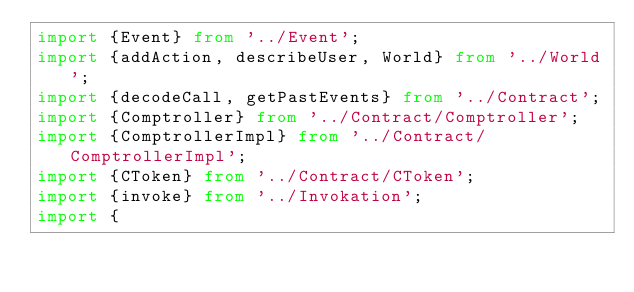Convert code to text. <code><loc_0><loc_0><loc_500><loc_500><_TypeScript_>import {Event} from '../Event';
import {addAction, describeUser, World} from '../World';
import {decodeCall, getPastEvents} from '../Contract';
import {Comptroller} from '../Contract/Comptroller';
import {ComptrollerImpl} from '../Contract/ComptrollerImpl';
import {CToken} from '../Contract/CToken';
import {invoke} from '../Invokation';
import {</code> 